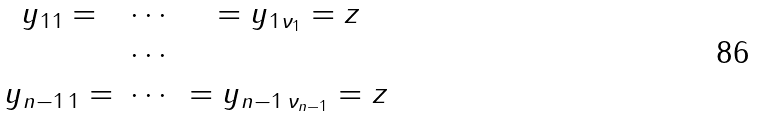<formula> <loc_0><loc_0><loc_500><loc_500>\begin{matrix} y _ { 1 1 } = & \cdots & = y _ { 1 \nu _ { 1 } } = z \\ & \cdots & \\ y _ { n - 1 \, 1 } = & \cdots & = y _ { n - 1 \, \nu _ { n - 1 } } = z \\ \end{matrix}</formula> 